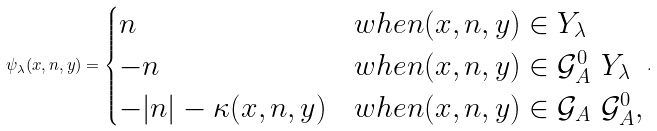<formula> <loc_0><loc_0><loc_500><loc_500>\psi _ { \lambda } ( x , n , y ) = \begin{cases} n & w h e n ( x , n , y ) \in Y _ { \lambda } \\ - n & w h e n ( x , n , y ) \in \mathcal { G } ^ { 0 } _ { A } \ Y _ { \lambda } \\ - | n | - \kappa ( x , n , y ) & w h e n ( x , n , y ) \in \mathcal { G } _ { A } \ \mathcal { G } ^ { 0 } _ { A } , \end{cases} .</formula> 